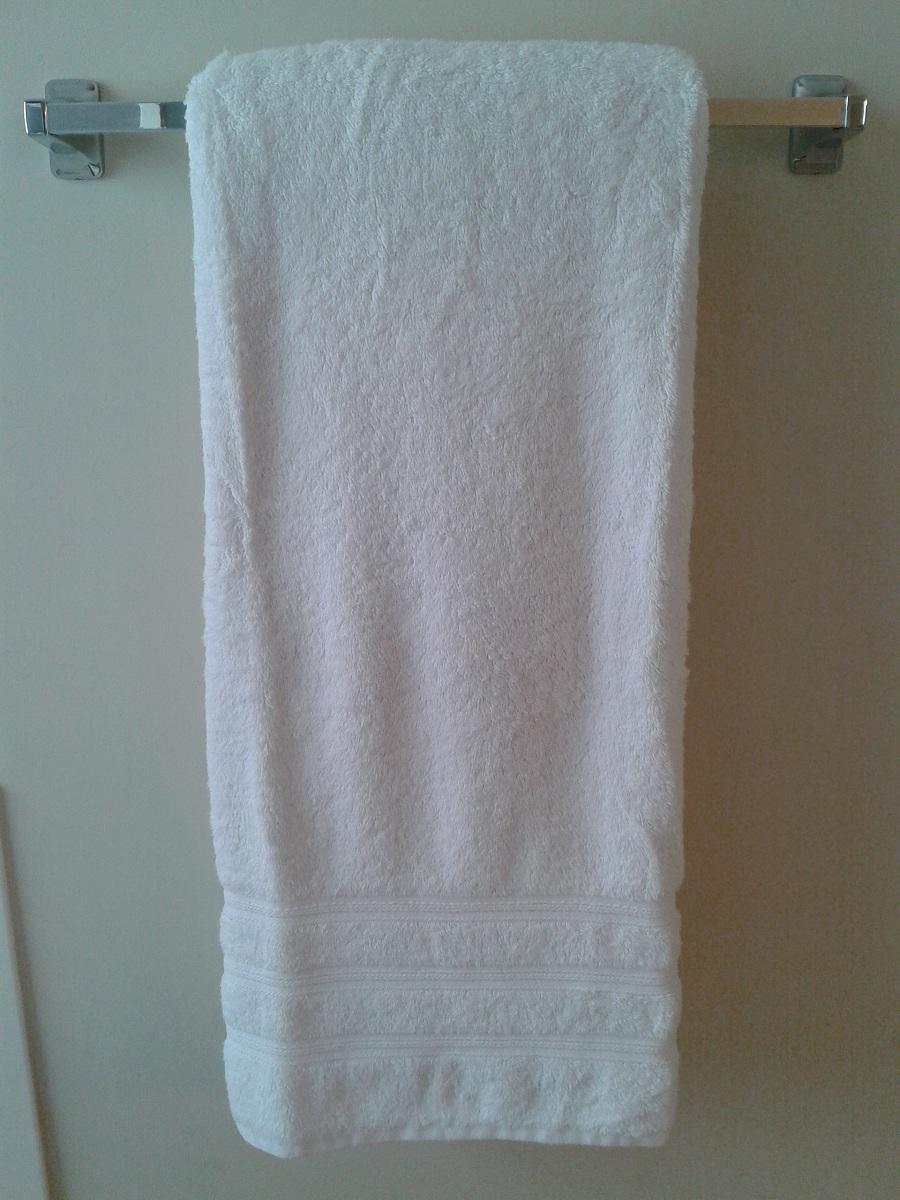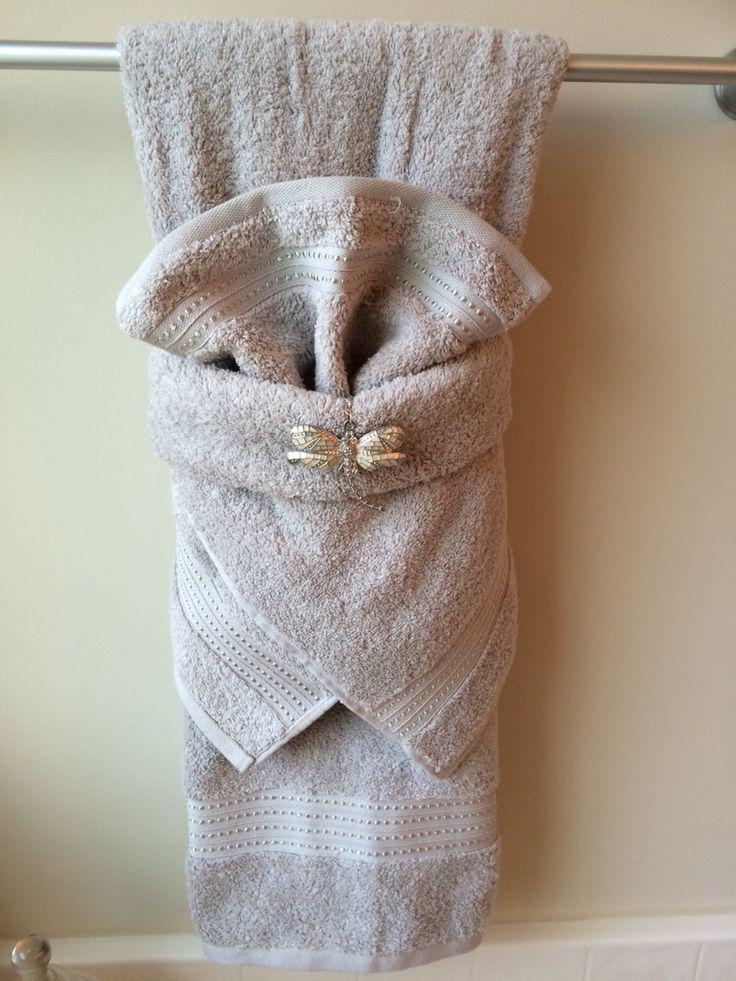The first image is the image on the left, the second image is the image on the right. For the images shown, is this caption "In the left image, we see one white towel, on a rack." true? Answer yes or no. Yes. The first image is the image on the left, the second image is the image on the right. Considering the images on both sides, is "In one image, the small hand towel is light blue and the larger bath towel behind it is white." valid? Answer yes or no. No. 